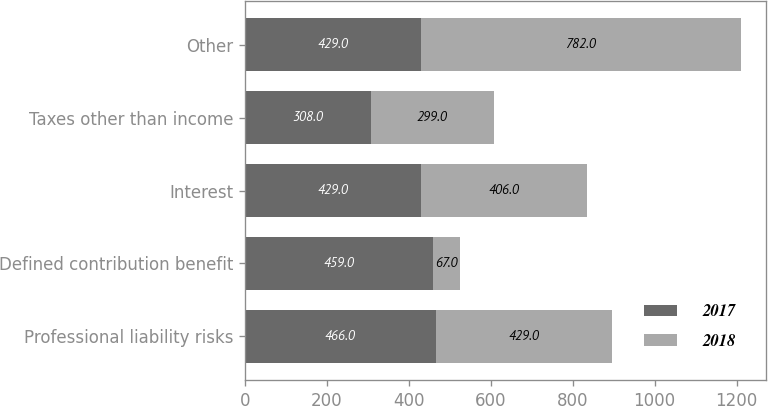Convert chart. <chart><loc_0><loc_0><loc_500><loc_500><stacked_bar_chart><ecel><fcel>Professional liability risks<fcel>Defined contribution benefit<fcel>Interest<fcel>Taxes other than income<fcel>Other<nl><fcel>2017<fcel>466<fcel>459<fcel>429<fcel>308<fcel>429<nl><fcel>2018<fcel>429<fcel>67<fcel>406<fcel>299<fcel>782<nl></chart> 